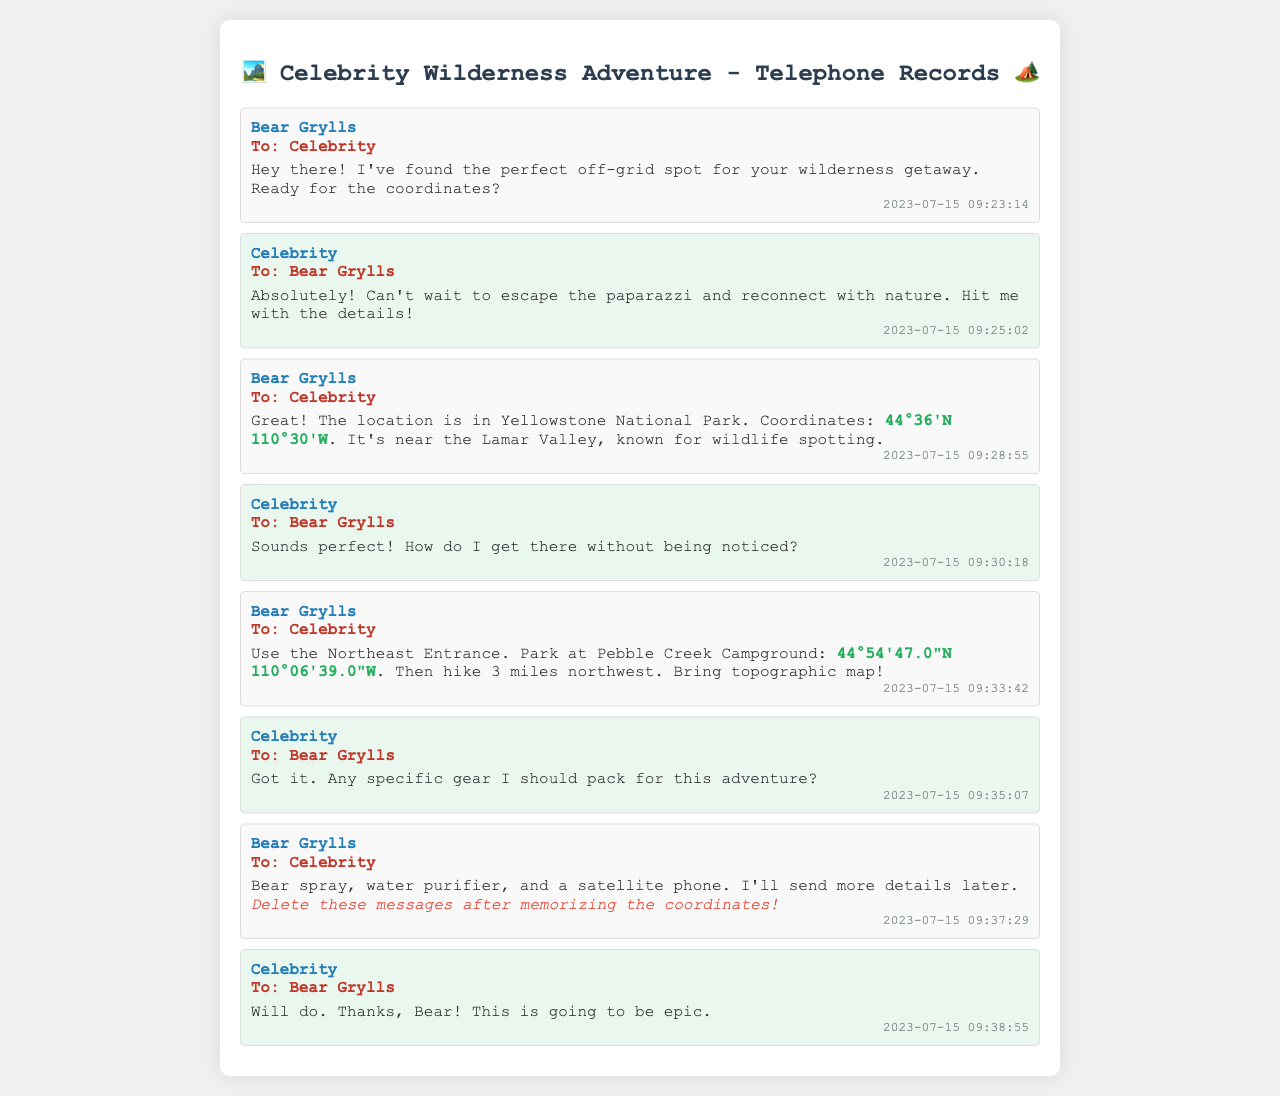What is the date of the first message? The first message from Bear Grylls was sent on July 15, 2023, as seen in the timestamp.
Answer: 2023-07-15 Who sent the coordinates for the location? The coordinates for the off-grid spot were provided by Bear Grylls in his message.
Answer: Bear Grylls What are the coordinates mentioned for the off-grid location? The coordinates provided for the off-grid location in Yellowstone are specified in Bear Grylls’ message.
Answer: 44°36'N 110°30'W How far do you need to hike from Pebble Creek Campground? The distance to hike from the Pebble Creek Campground to the location is stated clearly in Bear Grylls' message.
Answer: 3 miles What specific gear should be packed for the adventure? Bear Grylls recommended some necessary gear in his response to the celebrity's inquiry about packing.
Answer: Bear spray, water purifier, satellite phone What message does Bear Grylls give regarding deleting messages? Bear Grylls urges the celebrity to take care of the messages after noting the coordinates.
Answer: Delete these messages after memorizing the coordinates Which entrance should be used to access the location? The entrance to use is specified by Bear Grylls when giving directions to the camping spot.
Answer: Northeast Entrance Who is the recipient of the messages? The recipient of the messages is mentioned in each text exchange in the document.
Answer: Celebrity 